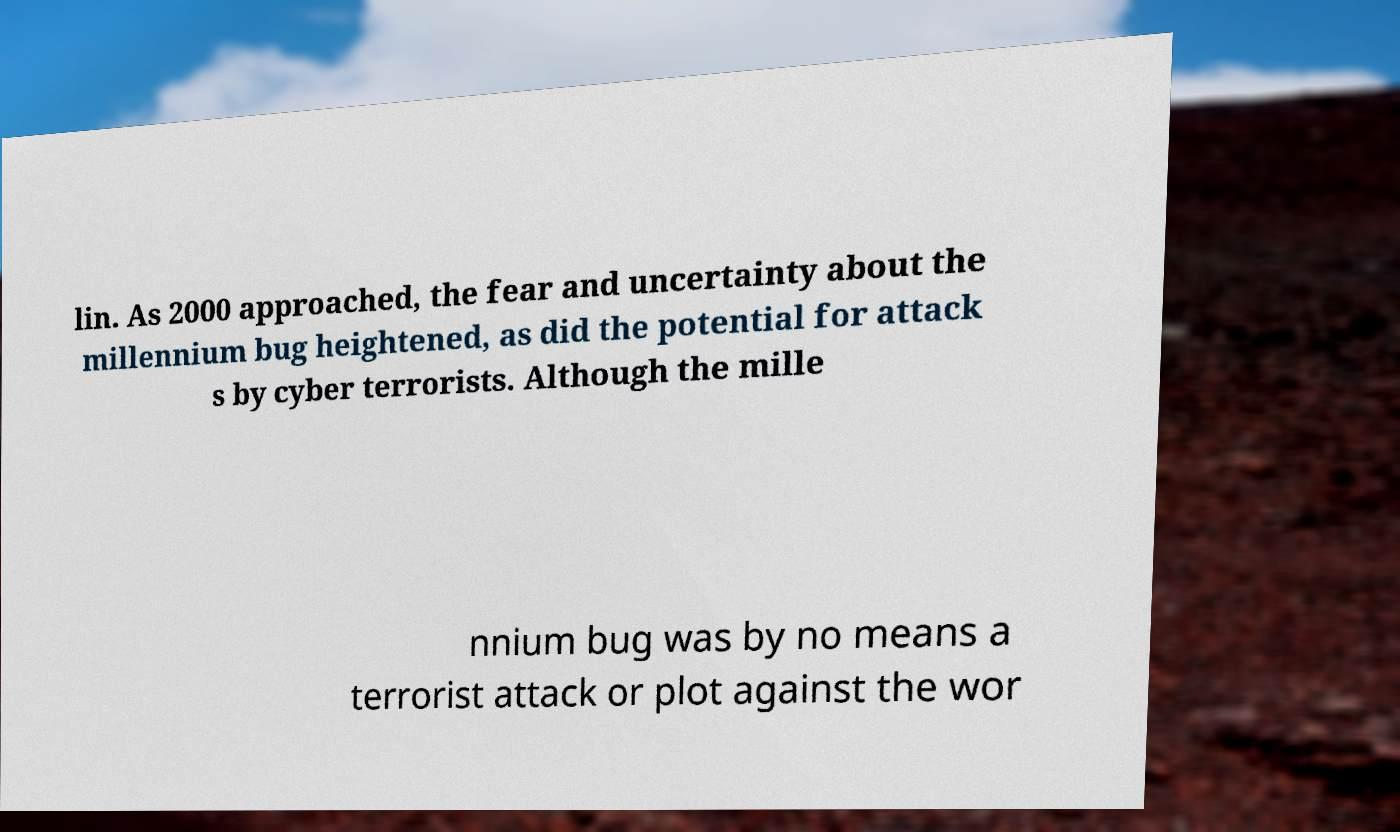Please read and relay the text visible in this image. What does it say? lin. As 2000 approached, the fear and uncertainty about the millennium bug heightened, as did the potential for attack s by cyber terrorists. Although the mille nnium bug was by no means a terrorist attack or plot against the wor 